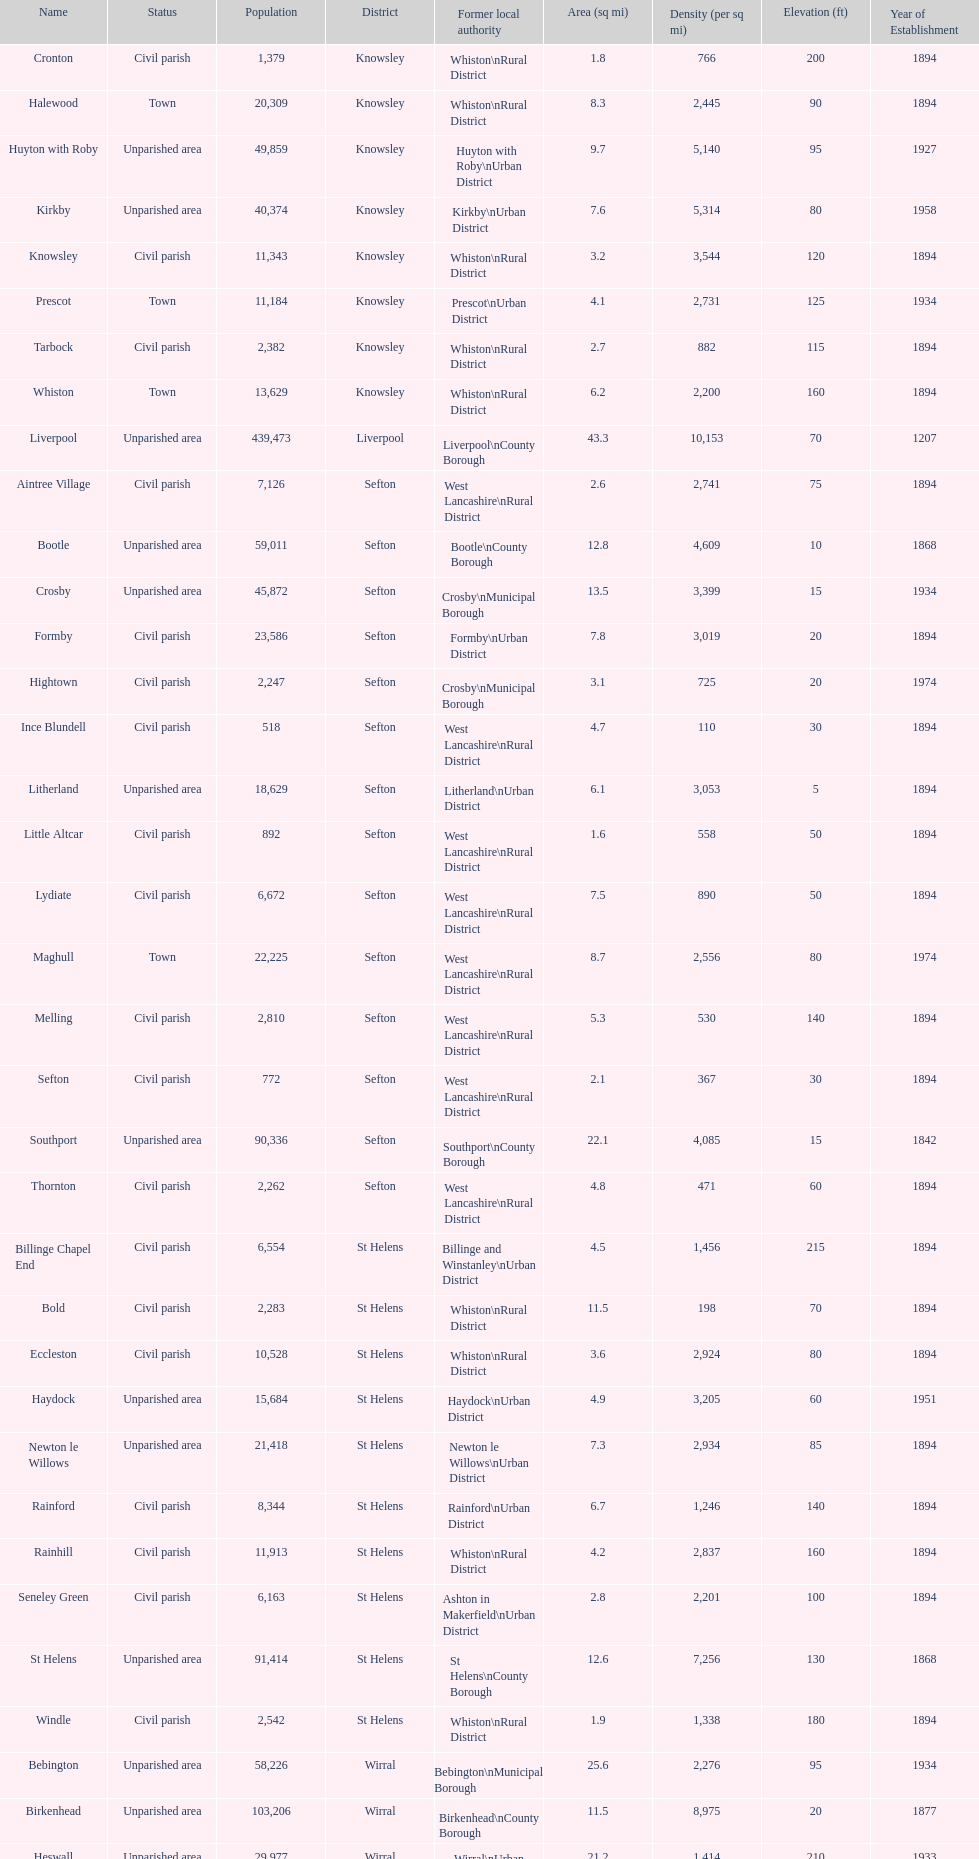How many civil parishes have population counts of at least 10,000? 4. 